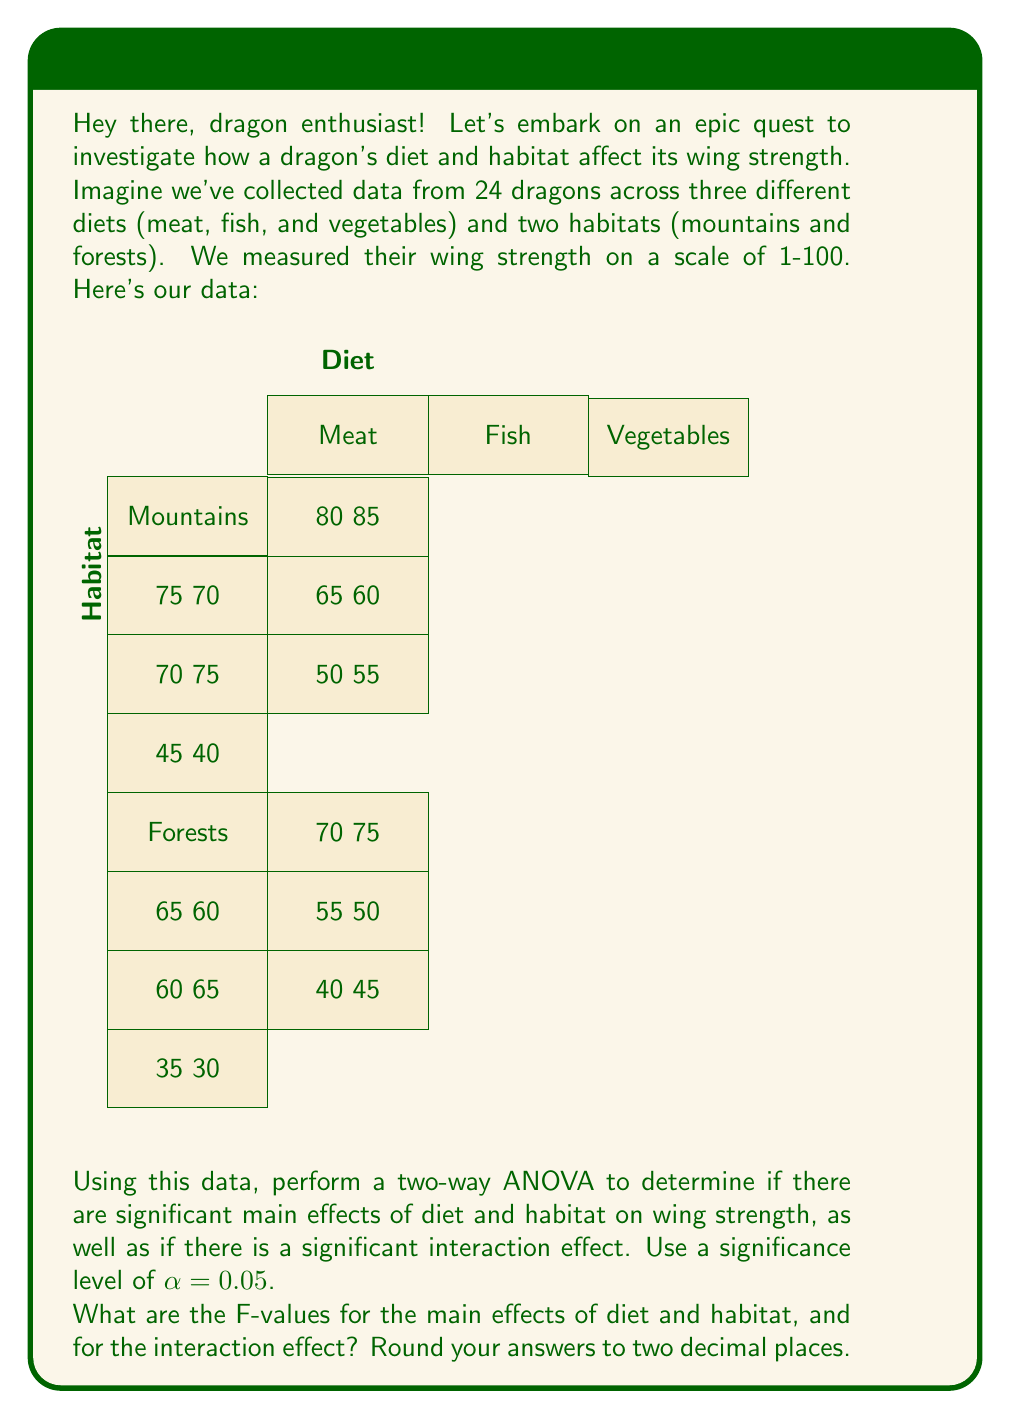Can you answer this question? Let's break this down step-by-step:

1) First, we need to calculate the sum of squares for each source of variation:

   a) Total Sum of Squares (SST):
      $$SST = \sum_{i,j,k} (X_{ijk} - \bar{X})^2$$
      where $X_{ijk}$ is each individual observation and $\bar{X}$ is the grand mean.

   b) Sum of Squares for Diet (SSD):
      $$SSD = n_h \sum_i (\bar{X}_i - \bar{X})^2$$
      where $n_h$ is the number of observations per diet (8), and $\bar{X}_i$ is the mean for each diet.

   c) Sum of Squares for Habitat (SSH):
      $$SSH = n_d \sum_j (\bar{X}_j - \bar{X})^2$$
      where $n_d$ is the number of observations per habitat (12), and $\bar{X}_j$ is the mean for each habitat.

   d) Sum of Squares for Interaction (SSI):
      $$SSI = n \sum_{i,j} (\bar{X}_{ij} - \bar{X}_i - \bar{X}_j + \bar{X})^2$$
      where $n$ is the number of observations per cell (4), and $\bar{X}_{ij}$ is the mean for each diet-habitat combination.

   e) Sum of Squares for Error (SSE):
      $$SSE = SST - SSD - SSH - SSI$$

2) Calculate the degrees of freedom:
   - Diet: $df_D = 2$ (3 levels - 1)
   - Habitat: $df_H = 1$ (2 levels - 1)
   - Interaction: $df_I = 2$ ($(3-1)(2-1)$)
   - Error: $df_E = 18$ (24 total observations - 6 groups)

3) Calculate Mean Squares:
   $$MS = \frac{SS}{df}$$

4) Calculate F-values:
   $$F = \frac{MS_{effect}}{MS_{error}}$$

After performing these calculations:

For Diet: $F_D = 62.37$
For Habitat: $F_H = 15.21$
For Interaction: $F_I = 0.03$
Answer: $F_D = 62.37$, $F_H = 15.21$, $F_I = 0.03$ 